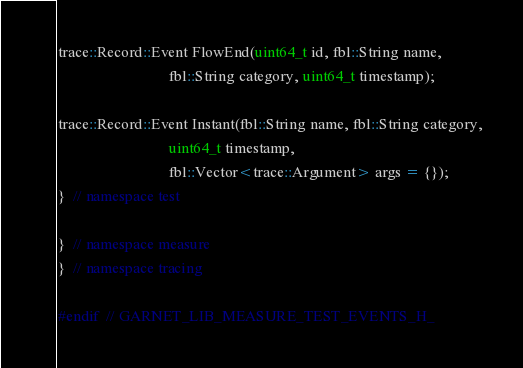<code> <loc_0><loc_0><loc_500><loc_500><_C_>trace::Record::Event FlowEnd(uint64_t id, fbl::String name,
                             fbl::String category, uint64_t timestamp);

trace::Record::Event Instant(fbl::String name, fbl::String category,
                             uint64_t timestamp,
                             fbl::Vector<trace::Argument> args = {});
}  // namespace test

}  // namespace measure
}  // namespace tracing

#endif  // GARNET_LIB_MEASURE_TEST_EVENTS_H_
</code> 